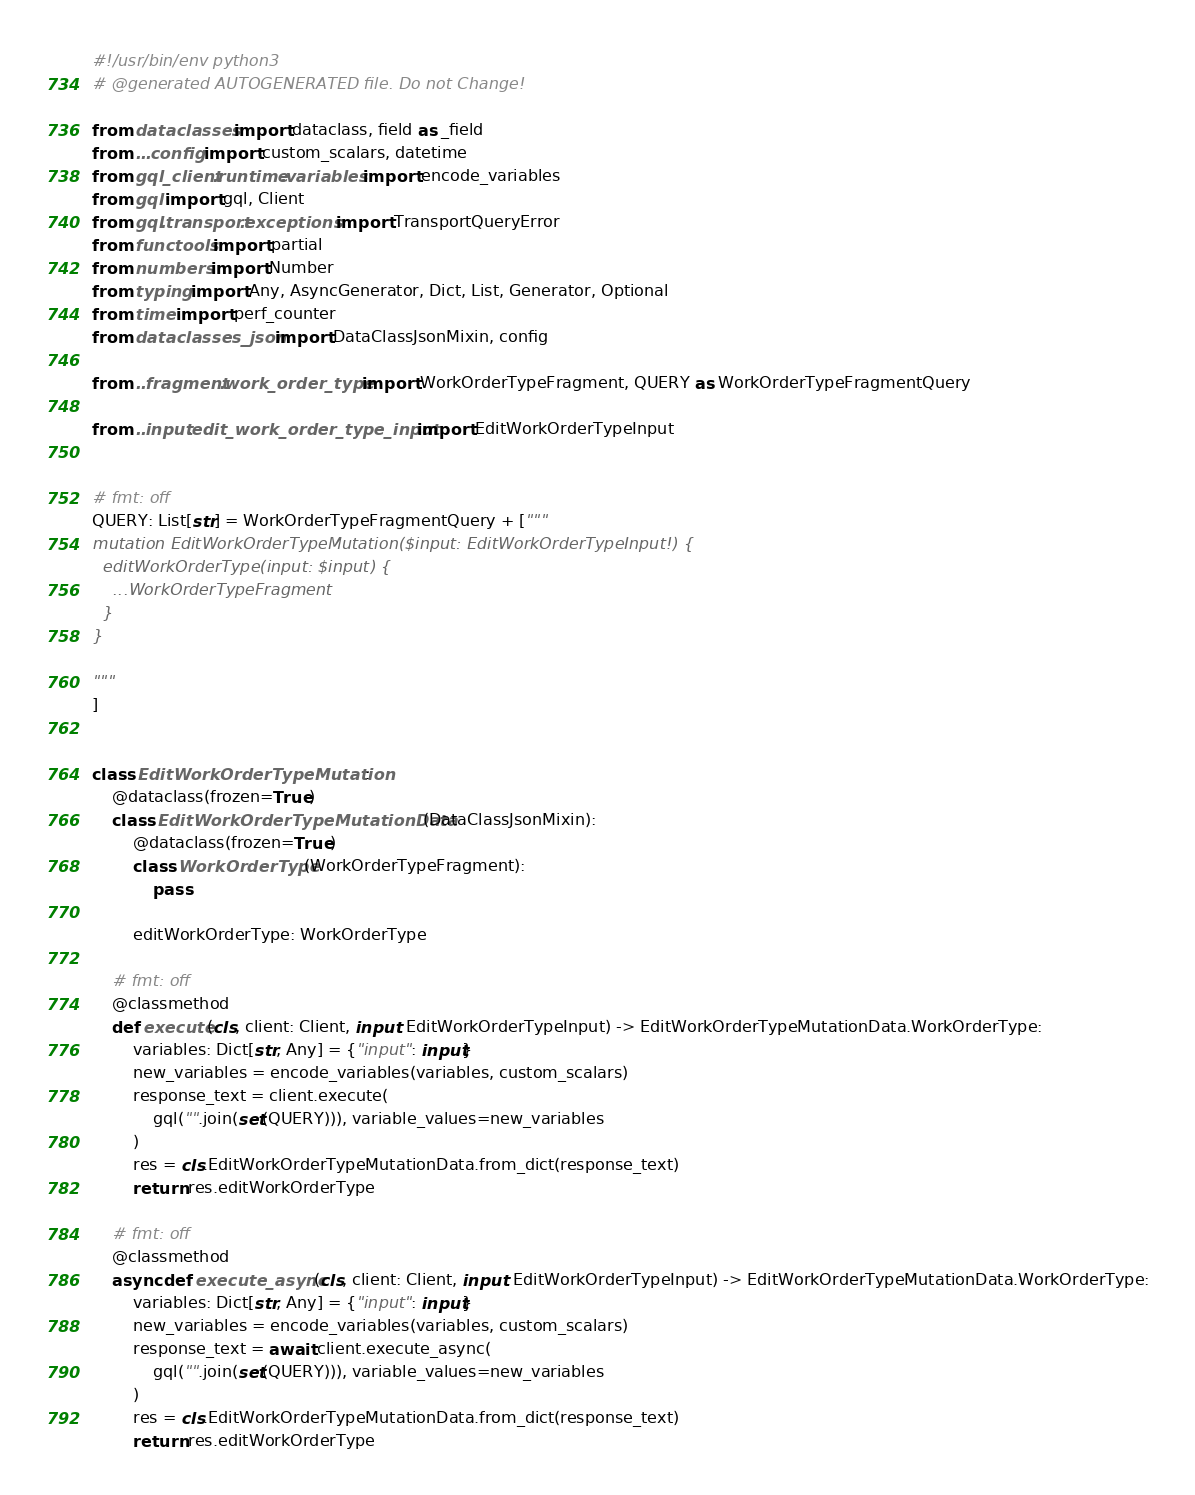Convert code to text. <code><loc_0><loc_0><loc_500><loc_500><_Python_>#!/usr/bin/env python3
# @generated AUTOGENERATED file. Do not Change!

from dataclasses import dataclass, field as _field
from ...config import custom_scalars, datetime
from gql_client.runtime.variables import encode_variables
from gql import gql, Client
from gql.transport.exceptions import TransportQueryError
from functools import partial
from numbers import Number
from typing import Any, AsyncGenerator, Dict, List, Generator, Optional
from time import perf_counter
from dataclasses_json import DataClassJsonMixin, config

from ..fragment.work_order_type import WorkOrderTypeFragment, QUERY as WorkOrderTypeFragmentQuery

from ..input.edit_work_order_type_input import EditWorkOrderTypeInput


# fmt: off
QUERY: List[str] = WorkOrderTypeFragmentQuery + ["""
mutation EditWorkOrderTypeMutation($input: EditWorkOrderTypeInput!) {
  editWorkOrderType(input: $input) {
    ...WorkOrderTypeFragment
  }
}

"""
]


class EditWorkOrderTypeMutation:
    @dataclass(frozen=True)
    class EditWorkOrderTypeMutationData(DataClassJsonMixin):
        @dataclass(frozen=True)
        class WorkOrderType(WorkOrderTypeFragment):
            pass

        editWorkOrderType: WorkOrderType

    # fmt: off
    @classmethod
    def execute(cls, client: Client, input: EditWorkOrderTypeInput) -> EditWorkOrderTypeMutationData.WorkOrderType:
        variables: Dict[str, Any] = {"input": input}
        new_variables = encode_variables(variables, custom_scalars)
        response_text = client.execute(
            gql("".join(set(QUERY))), variable_values=new_variables
        )
        res = cls.EditWorkOrderTypeMutationData.from_dict(response_text)
        return res.editWorkOrderType

    # fmt: off
    @classmethod
    async def execute_async(cls, client: Client, input: EditWorkOrderTypeInput) -> EditWorkOrderTypeMutationData.WorkOrderType:
        variables: Dict[str, Any] = {"input": input}
        new_variables = encode_variables(variables, custom_scalars)
        response_text = await client.execute_async(
            gql("".join(set(QUERY))), variable_values=new_variables
        )
        res = cls.EditWorkOrderTypeMutationData.from_dict(response_text)
        return res.editWorkOrderType
</code> 